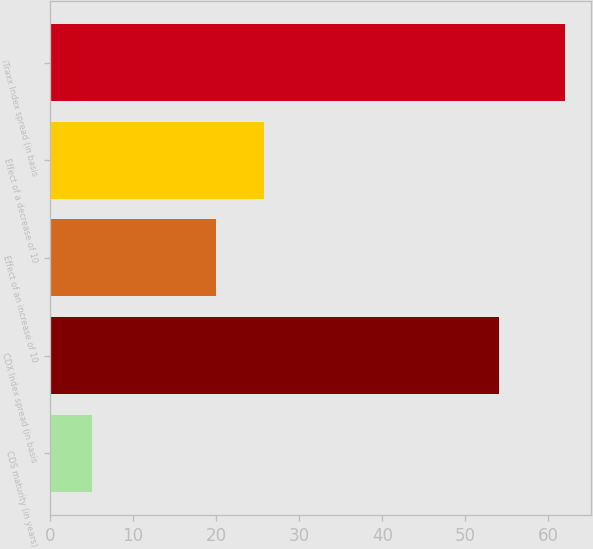Convert chart. <chart><loc_0><loc_0><loc_500><loc_500><bar_chart><fcel>CDS maturity (in years)<fcel>CDX Index spread (in basis<fcel>Effect of an increase of 10<fcel>Effect of a decrease of 10<fcel>iTraxx Index spread (in basis<nl><fcel>5<fcel>54<fcel>20<fcel>25.7<fcel>62<nl></chart> 